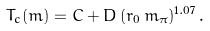Convert formula to latex. <formula><loc_0><loc_0><loc_500><loc_500>T _ { c } ( m ) = C + D \, ( r _ { 0 } \, m _ { \pi } ) ^ { 1 . 0 7 } \, .</formula> 